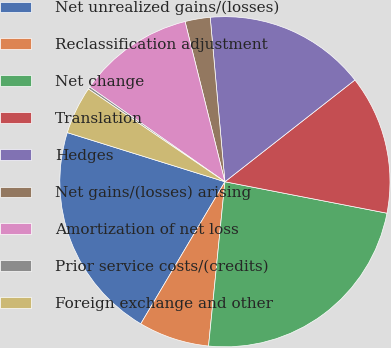<chart> <loc_0><loc_0><loc_500><loc_500><pie_chart><fcel>Net unrealized gains/(losses)<fcel>Reclassification adjustment<fcel>Net change<fcel>Translation<fcel>Hedges<fcel>Net gains/(losses) arising<fcel>Amortization of net loss<fcel>Prior service costs/(credits)<fcel>Foreign exchange and other<nl><fcel>21.3%<fcel>6.93%<fcel>23.53%<fcel>13.62%<fcel>15.85%<fcel>2.46%<fcel>11.39%<fcel>0.23%<fcel>4.69%<nl></chart> 